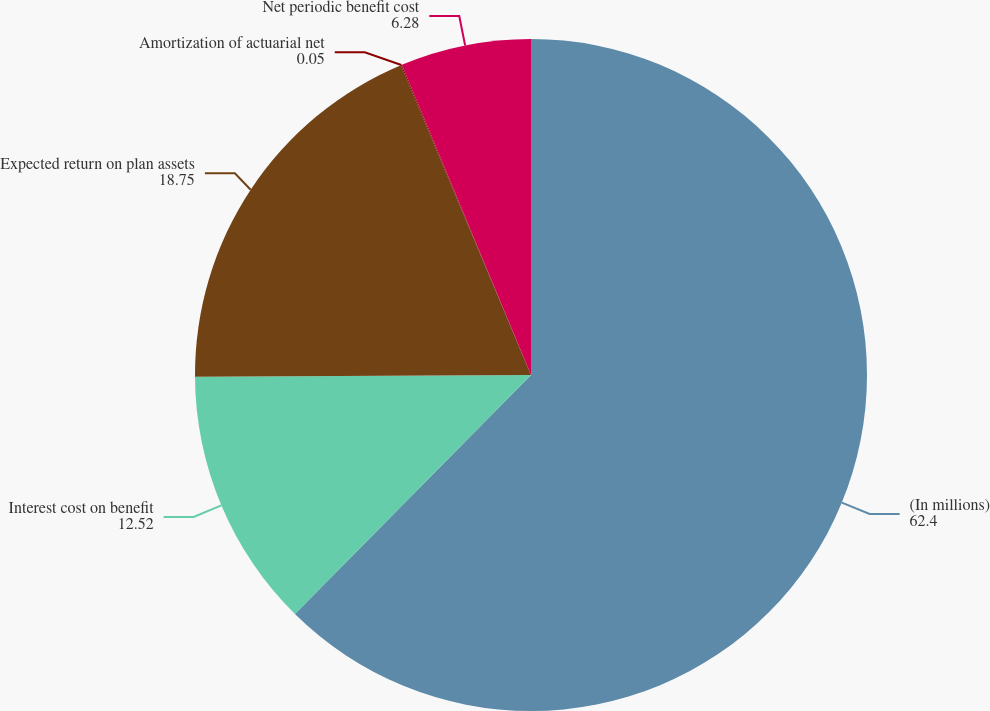<chart> <loc_0><loc_0><loc_500><loc_500><pie_chart><fcel>(In millions)<fcel>Interest cost on benefit<fcel>Expected return on plan assets<fcel>Amortization of actuarial net<fcel>Net periodic benefit cost<nl><fcel>62.4%<fcel>12.52%<fcel>18.75%<fcel>0.05%<fcel>6.28%<nl></chart> 